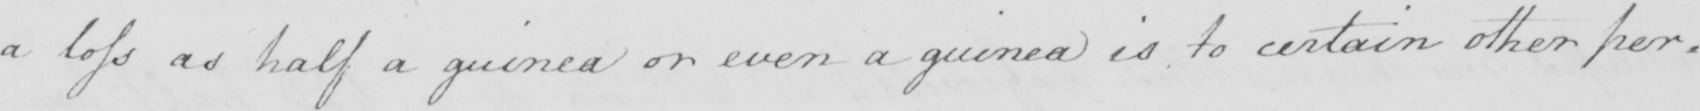Please transcribe the handwritten text in this image. a loss as a half a guinea or even a guinea is to certain other per= 